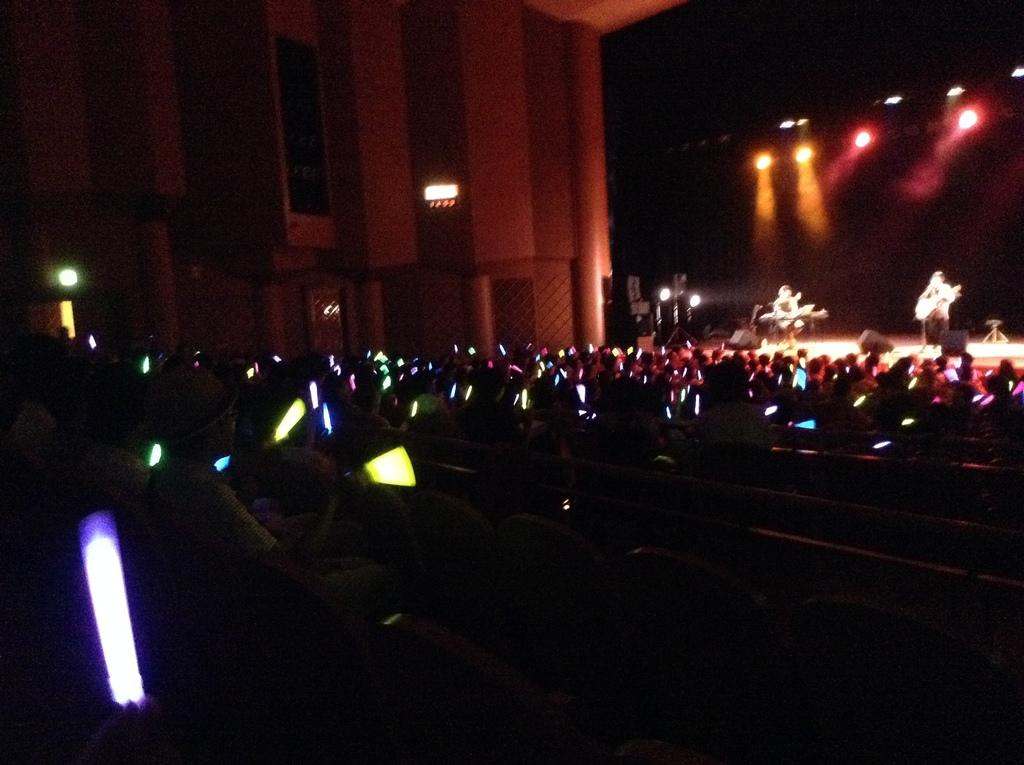What is happening in the image involving a group of people? Some people are playing musical instruments on a stage. Can you describe the setting where the people are playing music? There are lights visible in the image, which suggests that the performance is taking place in a well-lit area, possibly a concert or event venue. What type of seed can be seen growing into a tree in the image? There is no seed or tree present in the image; it features a group of people playing musical instruments on a stage. 